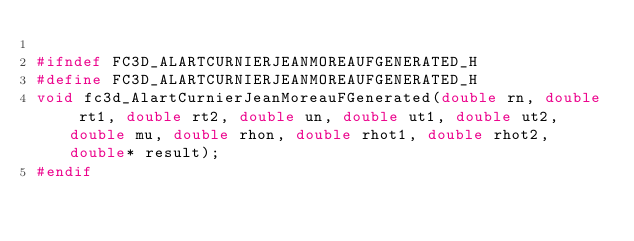Convert code to text. <code><loc_0><loc_0><loc_500><loc_500><_C_>
#ifndef FC3D_ALARTCURNIERJEANMOREAUFGENERATED_H
#define FC3D_ALARTCURNIERJEANMOREAUFGENERATED_H
void fc3d_AlartCurnierJeanMoreauFGenerated(double rn, double rt1, double rt2, double un, double ut1, double ut2, double mu, double rhon, double rhot1, double rhot2, double* result);
#endif
</code> 